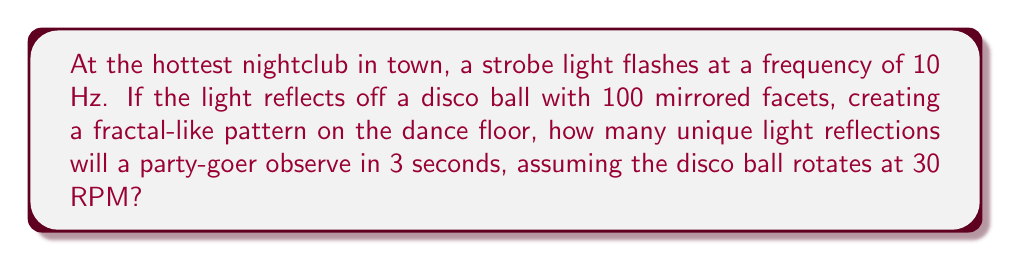Solve this math problem. Let's break this down step-by-step:

1. Understand the given information:
   - Strobe light frequency: 10 Hz (10 flashes per second)
   - Disco ball facets: 100
   - Disco ball rotation: 30 RPM (0.5 rotations per second)
   - Observation time: 3 seconds

2. Calculate the number of strobe flashes in 3 seconds:
   $$ \text{Flashes} = 10 \text{ Hz} \times 3 \text{ s} = 30 \text{ flashes} $$

3. Calculate the number of rotations the disco ball makes in 3 seconds:
   $$ \text{Rotations} = 0.5 \text{ rotations/s} \times 3 \text{ s} = 1.5 \text{ rotations} $$

4. Calculate the number of facets that pass a fixed point in 3 seconds:
   $$ \text{Facets passed} = 100 \text{ facets} \times 1.5 \text{ rotations} = 150 \text{ facets} $$

5. The number of unique reflections is the product of the number of flashes and the number of facets passed:
   $$ \text{Unique reflections} = 30 \text{ flashes} \times 150 \text{ facets} = 4500 $$

Therefore, a party-goer will observe 4500 unique light reflections in 3 seconds.
Answer: 4500 unique reflections 